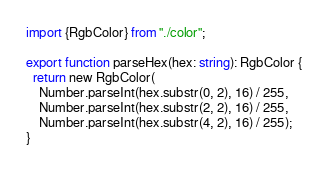Convert code to text. <code><loc_0><loc_0><loc_500><loc_500><_TypeScript_>import {RgbColor} from "./color";

export function parseHex(hex: string): RgbColor {
  return new RgbColor(
    Number.parseInt(hex.substr(0, 2), 16) / 255,
    Number.parseInt(hex.substr(2, 2), 16) / 255,
    Number.parseInt(hex.substr(4, 2), 16) / 255);
}
</code> 